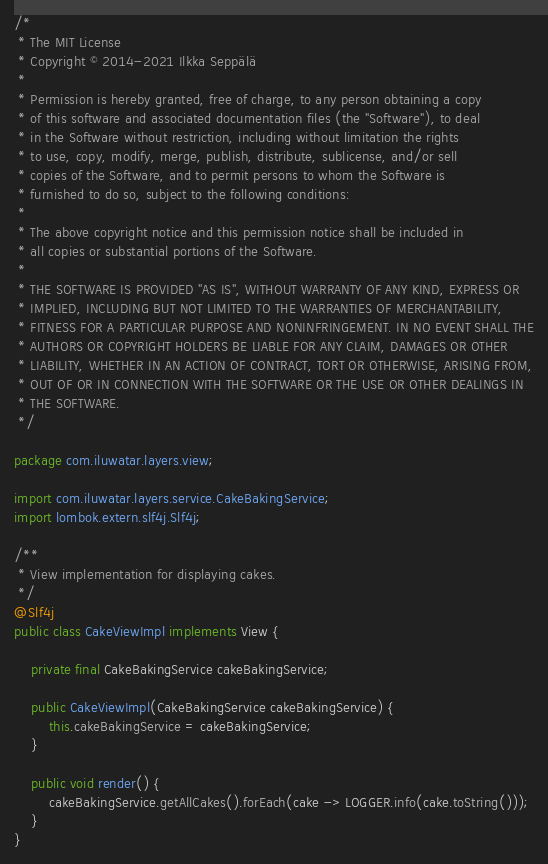<code> <loc_0><loc_0><loc_500><loc_500><_Java_>/*
 * The MIT License
 * Copyright © 2014-2021 Ilkka Seppälä
 *
 * Permission is hereby granted, free of charge, to any person obtaining a copy
 * of this software and associated documentation files (the "Software"), to deal
 * in the Software without restriction, including without limitation the rights
 * to use, copy, modify, merge, publish, distribute, sublicense, and/or sell
 * copies of the Software, and to permit persons to whom the Software is
 * furnished to do so, subject to the following conditions:
 *
 * The above copyright notice and this permission notice shall be included in
 * all copies or substantial portions of the Software.
 *
 * THE SOFTWARE IS PROVIDED "AS IS", WITHOUT WARRANTY OF ANY KIND, EXPRESS OR
 * IMPLIED, INCLUDING BUT NOT LIMITED TO THE WARRANTIES OF MERCHANTABILITY,
 * FITNESS FOR A PARTICULAR PURPOSE AND NONINFRINGEMENT. IN NO EVENT SHALL THE
 * AUTHORS OR COPYRIGHT HOLDERS BE LIABLE FOR ANY CLAIM, DAMAGES OR OTHER
 * LIABILITY, WHETHER IN AN ACTION OF CONTRACT, TORT OR OTHERWISE, ARISING FROM,
 * OUT OF OR IN CONNECTION WITH THE SOFTWARE OR THE USE OR OTHER DEALINGS IN
 * THE SOFTWARE.
 */

package com.iluwatar.layers.view;

import com.iluwatar.layers.service.CakeBakingService;
import lombok.extern.slf4j.Slf4j;

/**
 * View implementation for displaying cakes.
 */
@Slf4j
public class CakeViewImpl implements View {

    private final CakeBakingService cakeBakingService;

    public CakeViewImpl(CakeBakingService cakeBakingService) {
        this.cakeBakingService = cakeBakingService;
    }

    public void render() {
        cakeBakingService.getAllCakes().forEach(cake -> LOGGER.info(cake.toString()));
    }
}
</code> 